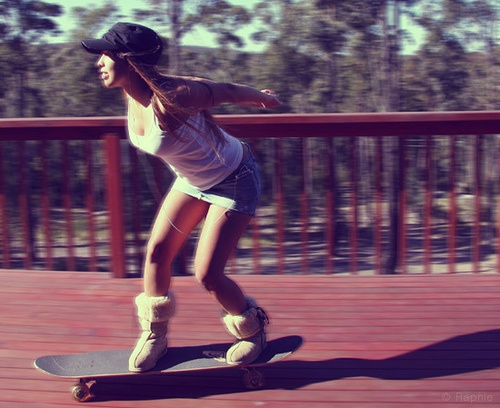Describe the objects in this image and their specific colors. I can see people in darkgray, purple, navy, and beige tones and skateboard in darkgray, navy, and brown tones in this image. 